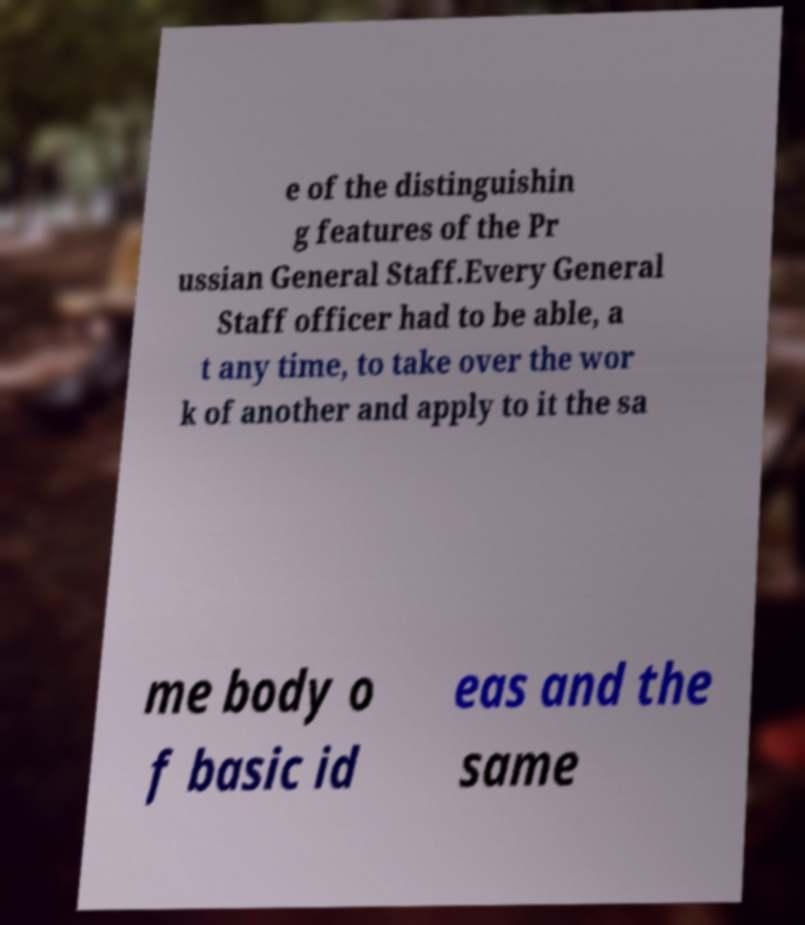Can you accurately transcribe the text from the provided image for me? e of the distinguishin g features of the Pr ussian General Staff.Every General Staff officer had to be able, a t any time, to take over the wor k of another and apply to it the sa me body o f basic id eas and the same 